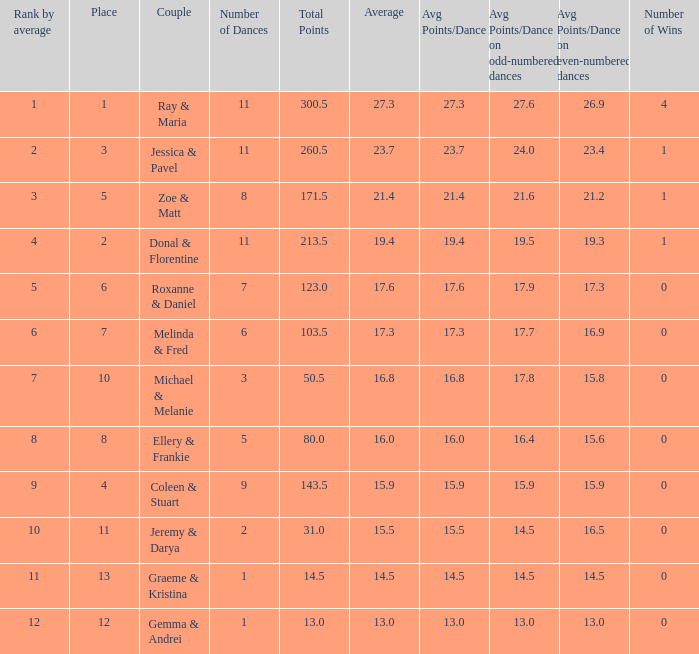If the total points is 50.5, what is the total number of dances? 1.0. 